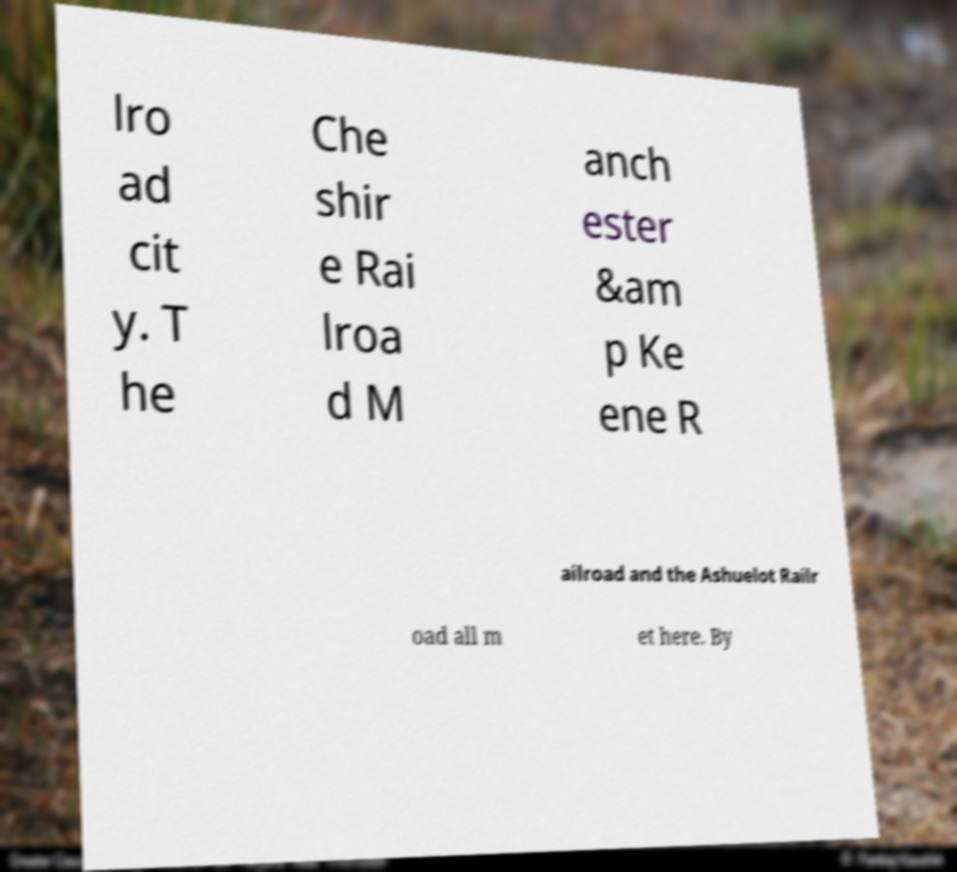Please read and relay the text visible in this image. What does it say? lro ad cit y. T he Che shir e Rai lroa d M anch ester &am p Ke ene R ailroad and the Ashuelot Railr oad all m et here. By 